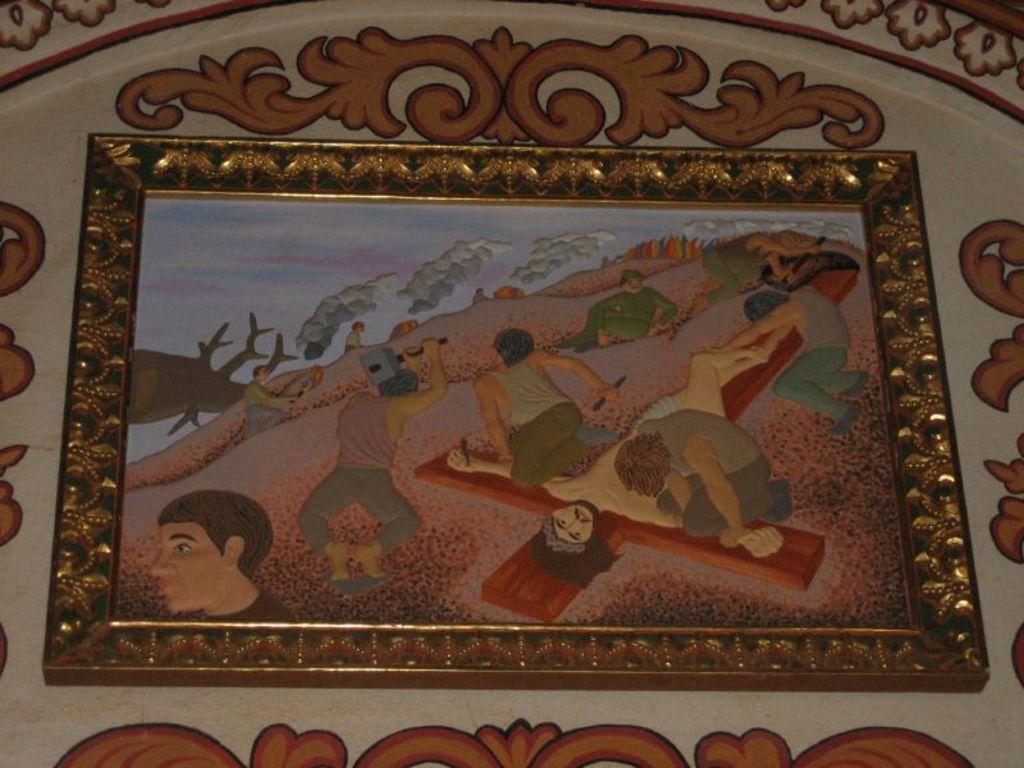What object can be seen in the image? There is a photo frame in the image. Where is the photo frame located? The photo frame is attached to a design wall. What type of coil is used to hang the photo frame on the design wall? There is no coil mentioned or visible in the image; the photo frame is simply attached to the design wall. 